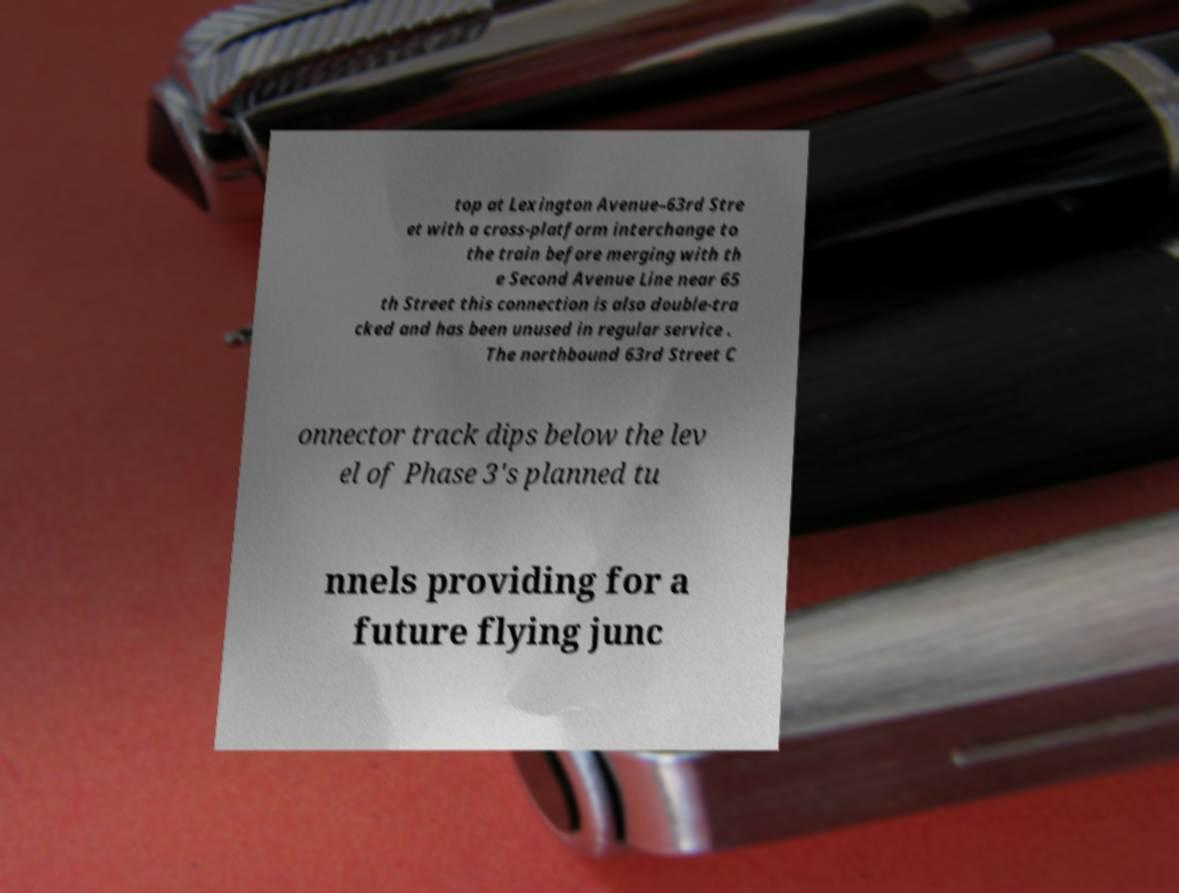There's text embedded in this image that I need extracted. Can you transcribe it verbatim? top at Lexington Avenue–63rd Stre et with a cross-platform interchange to the train before merging with th e Second Avenue Line near 65 th Street this connection is also double-tra cked and has been unused in regular service . The northbound 63rd Street C onnector track dips below the lev el of Phase 3's planned tu nnels providing for a future flying junc 